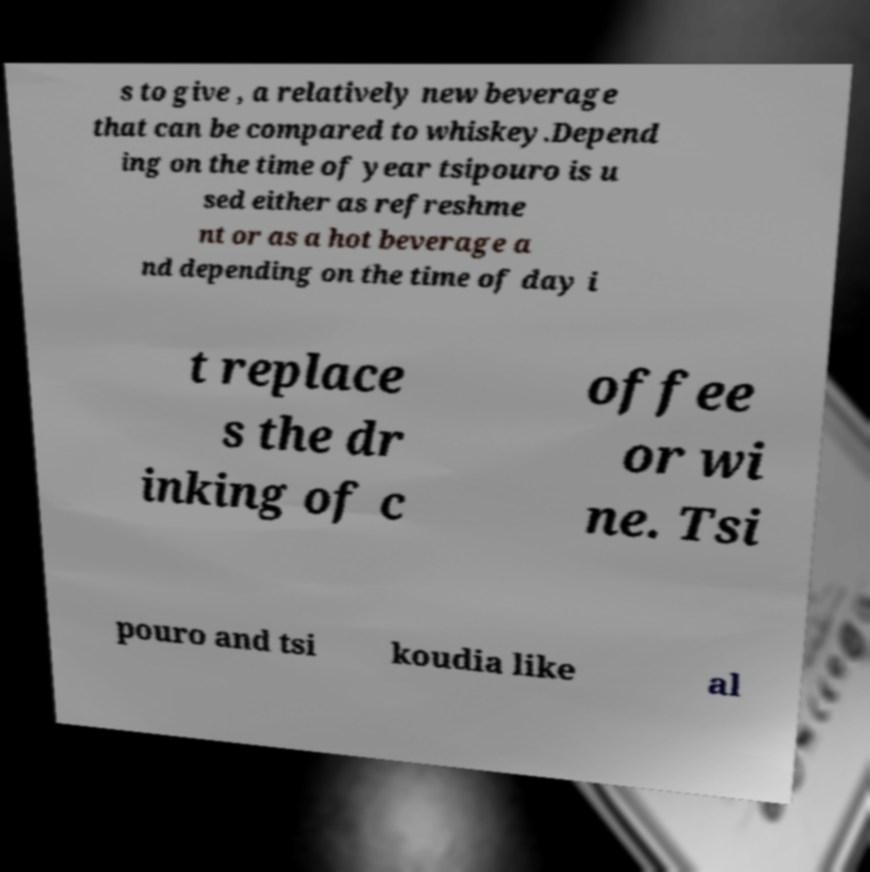What messages or text are displayed in this image? I need them in a readable, typed format. s to give , a relatively new beverage that can be compared to whiskey.Depend ing on the time of year tsipouro is u sed either as refreshme nt or as a hot beverage a nd depending on the time of day i t replace s the dr inking of c offee or wi ne. Tsi pouro and tsi koudia like al 